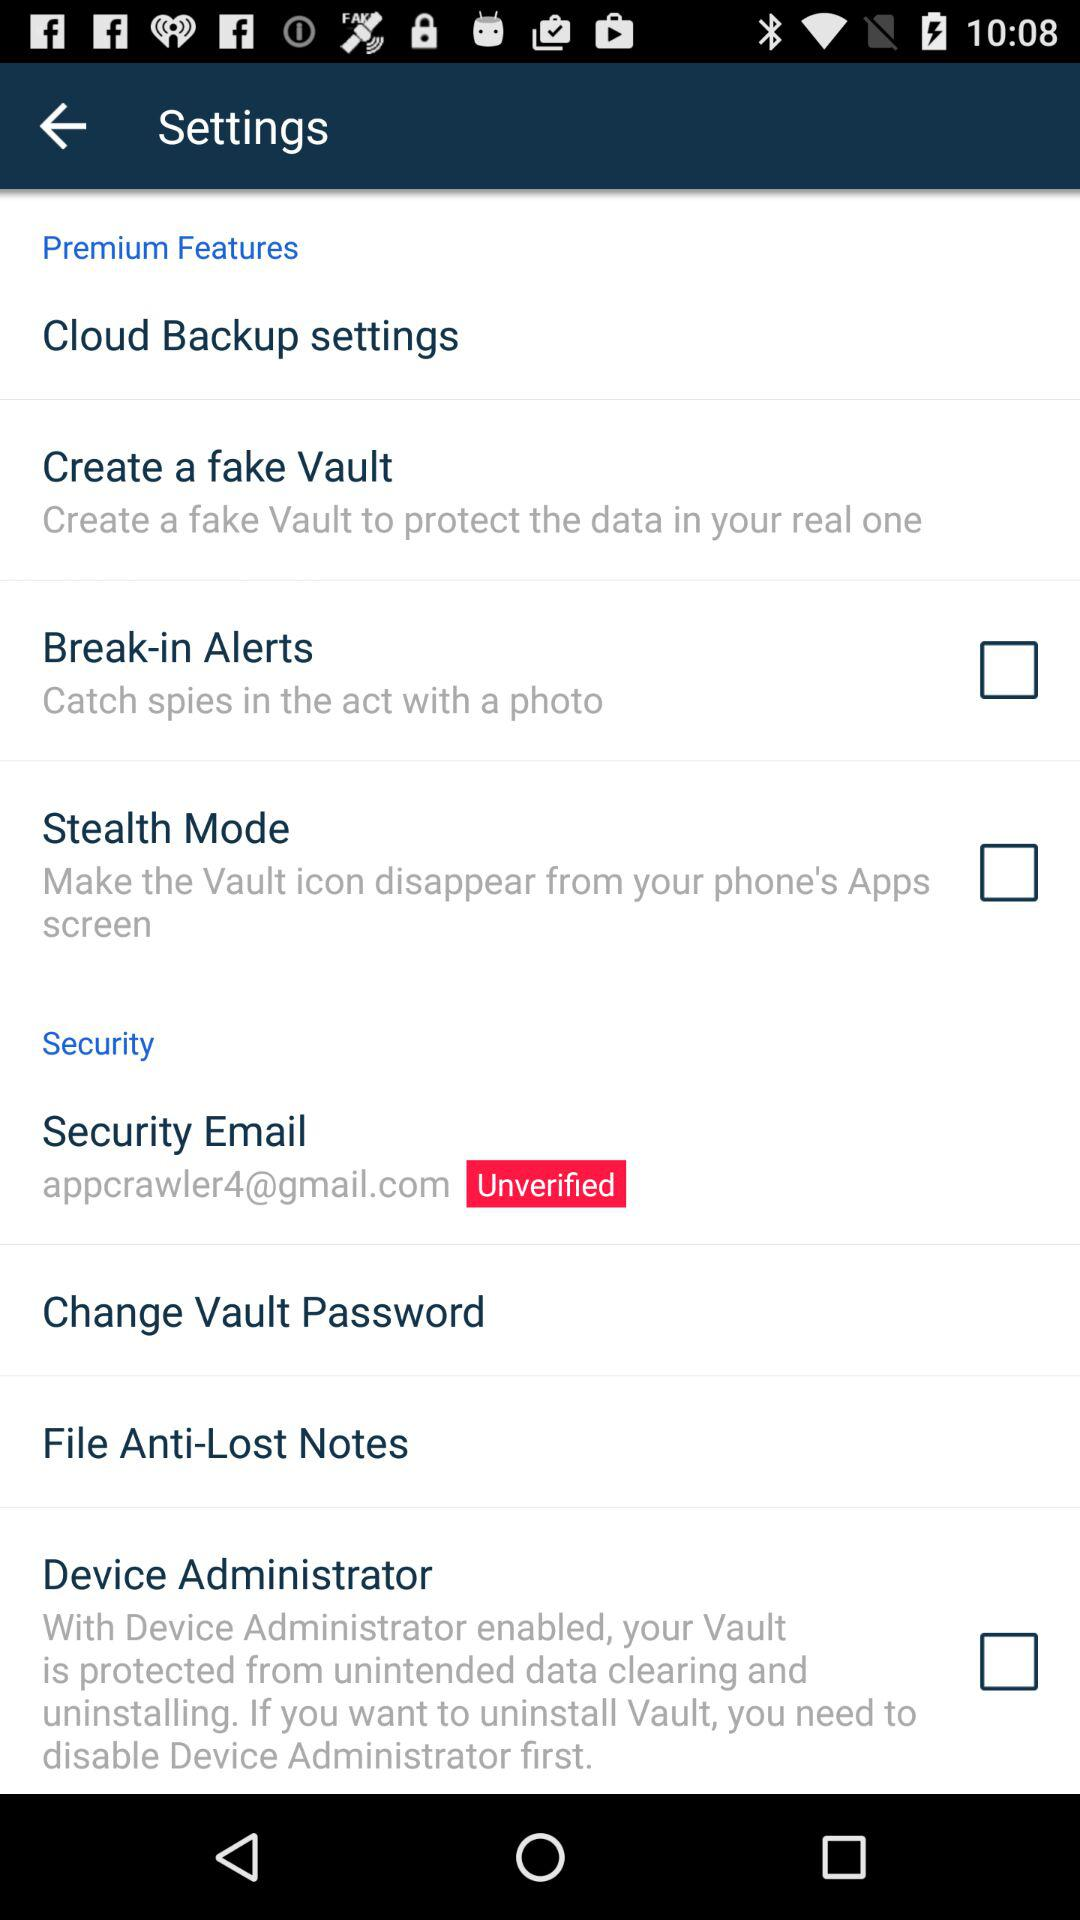What is the status of the "Stealth Mode"? The status is "off". 